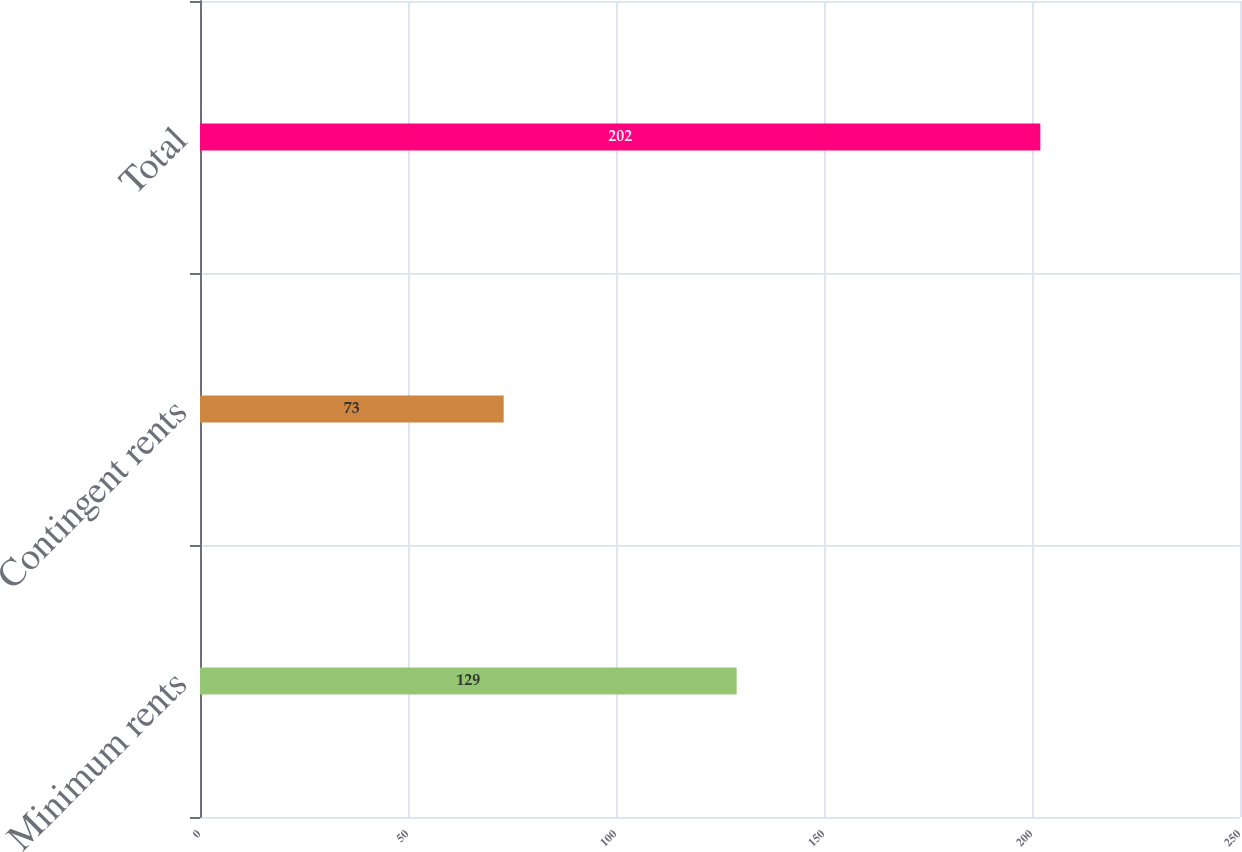<chart> <loc_0><loc_0><loc_500><loc_500><bar_chart><fcel>Minimum rents<fcel>Contingent rents<fcel>Total<nl><fcel>129<fcel>73<fcel>202<nl></chart> 